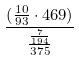<formula> <loc_0><loc_0><loc_500><loc_500>\frac { ( \frac { 1 0 } { 9 3 } \cdot 4 6 9 ) } { \frac { \frac { 7 } { 1 9 4 } } { 3 7 5 } }</formula> 